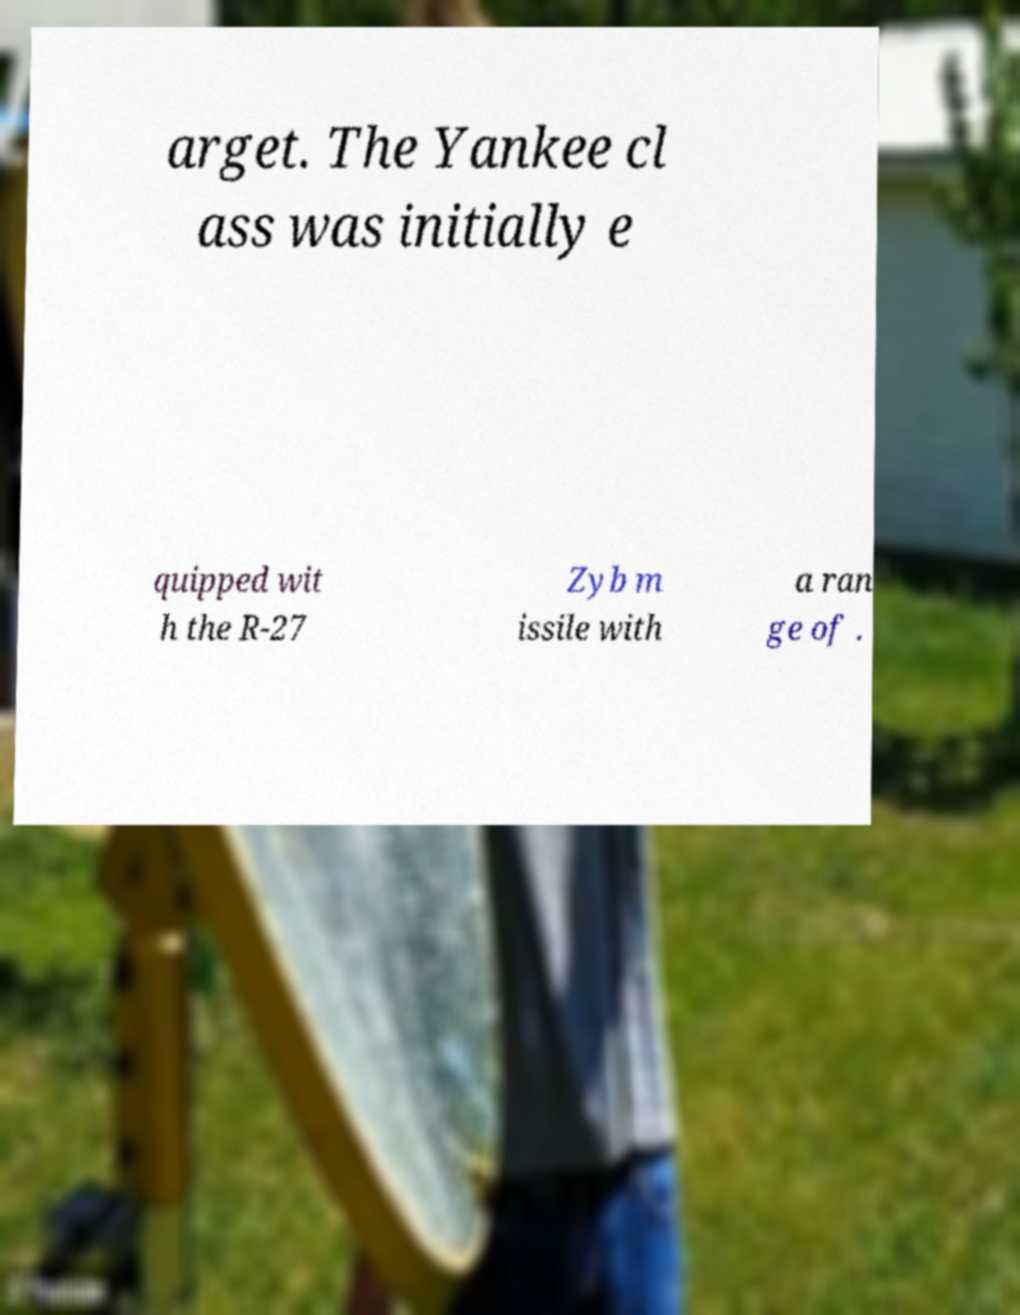Could you extract and type out the text from this image? arget. The Yankee cl ass was initially e quipped wit h the R-27 Zyb m issile with a ran ge of . 